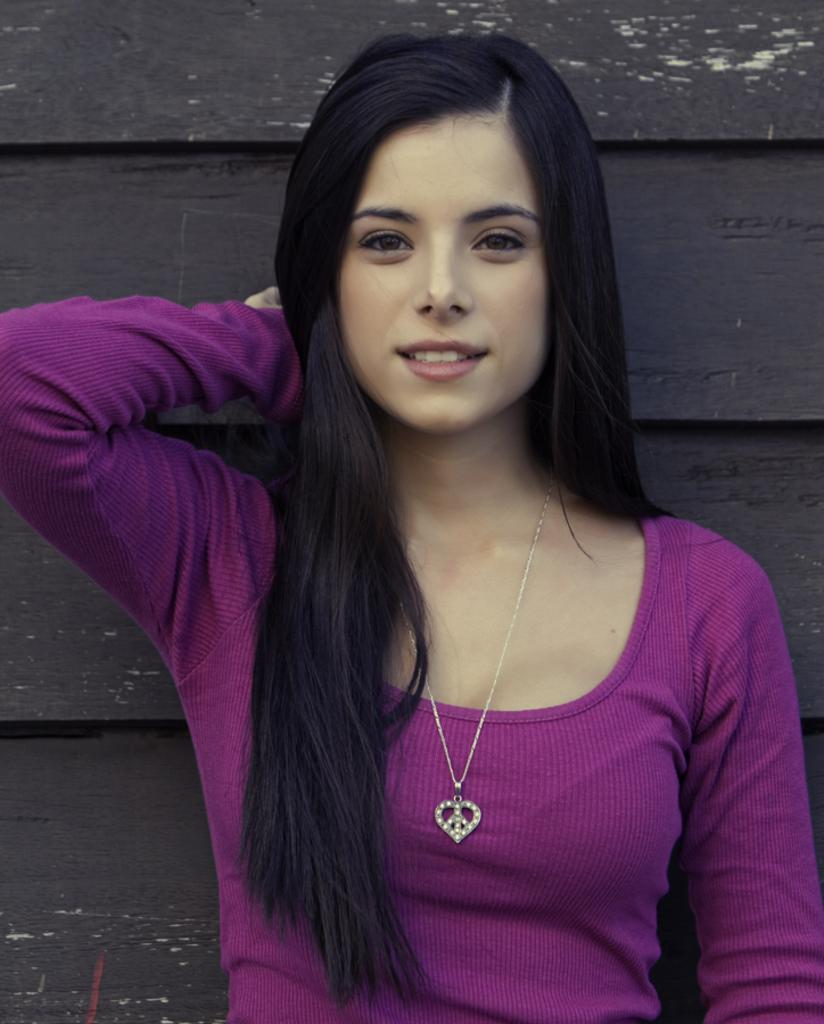Who is the main subject in the image? There is a girl in the image. What is the girl wearing? The girl is wearing a purple T-shirt. What is the girl doing in the image? The girl is standing and smiling, and she is posing for a photo. What is the color of the background in the image? The background of the image is black in color. What type of advice is the girl giving in the image? There is no indication in the image that the girl is giving any advice. What kind of powder is visible on the girl's face in the image? There is no powder visible on the girl's face in the image. 